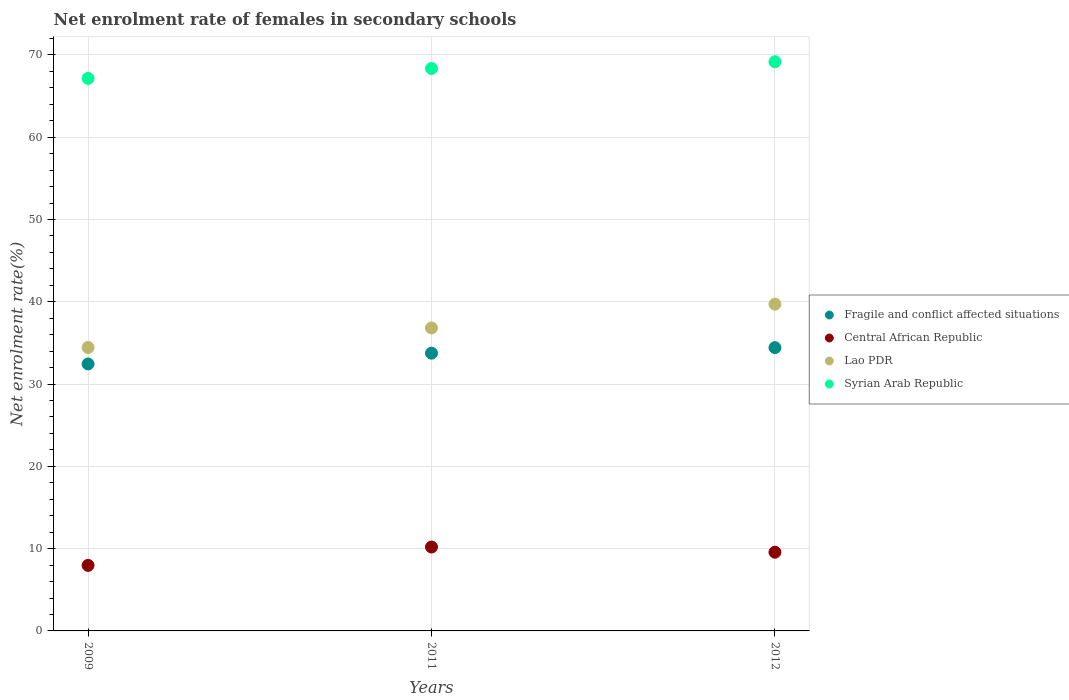How many different coloured dotlines are there?
Provide a succinct answer. 4. What is the net enrolment rate of females in secondary schools in Fragile and conflict affected situations in 2009?
Your response must be concise. 32.44. Across all years, what is the maximum net enrolment rate of females in secondary schools in Central African Republic?
Ensure brevity in your answer.  10.2. Across all years, what is the minimum net enrolment rate of females in secondary schools in Fragile and conflict affected situations?
Ensure brevity in your answer.  32.44. What is the total net enrolment rate of females in secondary schools in Syrian Arab Republic in the graph?
Your response must be concise. 204.66. What is the difference between the net enrolment rate of females in secondary schools in Lao PDR in 2009 and that in 2012?
Ensure brevity in your answer.  -5.27. What is the difference between the net enrolment rate of females in secondary schools in Lao PDR in 2009 and the net enrolment rate of females in secondary schools in Syrian Arab Republic in 2012?
Provide a short and direct response. -34.72. What is the average net enrolment rate of females in secondary schools in Fragile and conflict affected situations per year?
Provide a short and direct response. 33.54. In the year 2012, what is the difference between the net enrolment rate of females in secondary schools in Central African Republic and net enrolment rate of females in secondary schools in Syrian Arab Republic?
Provide a short and direct response. -59.6. What is the ratio of the net enrolment rate of females in secondary schools in Lao PDR in 2011 to that in 2012?
Give a very brief answer. 0.93. Is the net enrolment rate of females in secondary schools in Lao PDR in 2011 less than that in 2012?
Give a very brief answer. Yes. Is the difference between the net enrolment rate of females in secondary schools in Central African Republic in 2009 and 2011 greater than the difference between the net enrolment rate of females in secondary schools in Syrian Arab Republic in 2009 and 2011?
Ensure brevity in your answer.  No. What is the difference between the highest and the second highest net enrolment rate of females in secondary schools in Central African Republic?
Your response must be concise. 0.63. What is the difference between the highest and the lowest net enrolment rate of females in secondary schools in Lao PDR?
Offer a very short reply. 5.27. In how many years, is the net enrolment rate of females in secondary schools in Syrian Arab Republic greater than the average net enrolment rate of females in secondary schools in Syrian Arab Republic taken over all years?
Provide a succinct answer. 2. Is the sum of the net enrolment rate of females in secondary schools in Syrian Arab Republic in 2009 and 2011 greater than the maximum net enrolment rate of females in secondary schools in Lao PDR across all years?
Your answer should be compact. Yes. Is it the case that in every year, the sum of the net enrolment rate of females in secondary schools in Central African Republic and net enrolment rate of females in secondary schools in Fragile and conflict affected situations  is greater than the sum of net enrolment rate of females in secondary schools in Lao PDR and net enrolment rate of females in secondary schools in Syrian Arab Republic?
Offer a terse response. No. Is the net enrolment rate of females in secondary schools in Central African Republic strictly less than the net enrolment rate of females in secondary schools in Syrian Arab Republic over the years?
Your answer should be very brief. Yes. How many years are there in the graph?
Your answer should be compact. 3. What is the difference between two consecutive major ticks on the Y-axis?
Offer a terse response. 10. How many legend labels are there?
Offer a very short reply. 4. How are the legend labels stacked?
Provide a short and direct response. Vertical. What is the title of the graph?
Ensure brevity in your answer.  Net enrolment rate of females in secondary schools. Does "East Asia (developing only)" appear as one of the legend labels in the graph?
Ensure brevity in your answer.  No. What is the label or title of the Y-axis?
Offer a very short reply. Net enrolment rate(%). What is the Net enrolment rate(%) in Fragile and conflict affected situations in 2009?
Make the answer very short. 32.44. What is the Net enrolment rate(%) in Central African Republic in 2009?
Provide a succinct answer. 7.96. What is the Net enrolment rate(%) in Lao PDR in 2009?
Keep it short and to the point. 34.45. What is the Net enrolment rate(%) of Syrian Arab Republic in 2009?
Provide a short and direct response. 67.14. What is the Net enrolment rate(%) of Fragile and conflict affected situations in 2011?
Your answer should be compact. 33.76. What is the Net enrolment rate(%) in Central African Republic in 2011?
Offer a terse response. 10.2. What is the Net enrolment rate(%) in Lao PDR in 2011?
Provide a succinct answer. 36.82. What is the Net enrolment rate(%) of Syrian Arab Republic in 2011?
Make the answer very short. 68.35. What is the Net enrolment rate(%) of Fragile and conflict affected situations in 2012?
Offer a very short reply. 34.43. What is the Net enrolment rate(%) of Central African Republic in 2012?
Keep it short and to the point. 9.57. What is the Net enrolment rate(%) in Lao PDR in 2012?
Provide a succinct answer. 39.71. What is the Net enrolment rate(%) in Syrian Arab Republic in 2012?
Provide a short and direct response. 69.17. Across all years, what is the maximum Net enrolment rate(%) of Fragile and conflict affected situations?
Give a very brief answer. 34.43. Across all years, what is the maximum Net enrolment rate(%) of Central African Republic?
Keep it short and to the point. 10.2. Across all years, what is the maximum Net enrolment rate(%) of Lao PDR?
Offer a terse response. 39.71. Across all years, what is the maximum Net enrolment rate(%) of Syrian Arab Republic?
Make the answer very short. 69.17. Across all years, what is the minimum Net enrolment rate(%) of Fragile and conflict affected situations?
Your answer should be compact. 32.44. Across all years, what is the minimum Net enrolment rate(%) of Central African Republic?
Offer a terse response. 7.96. Across all years, what is the minimum Net enrolment rate(%) in Lao PDR?
Your answer should be compact. 34.45. Across all years, what is the minimum Net enrolment rate(%) of Syrian Arab Republic?
Offer a terse response. 67.14. What is the total Net enrolment rate(%) of Fragile and conflict affected situations in the graph?
Keep it short and to the point. 100.63. What is the total Net enrolment rate(%) of Central African Republic in the graph?
Make the answer very short. 27.73. What is the total Net enrolment rate(%) in Lao PDR in the graph?
Your answer should be very brief. 110.98. What is the total Net enrolment rate(%) of Syrian Arab Republic in the graph?
Give a very brief answer. 204.66. What is the difference between the Net enrolment rate(%) of Fragile and conflict affected situations in 2009 and that in 2011?
Keep it short and to the point. -1.31. What is the difference between the Net enrolment rate(%) of Central African Republic in 2009 and that in 2011?
Make the answer very short. -2.23. What is the difference between the Net enrolment rate(%) of Lao PDR in 2009 and that in 2011?
Your answer should be very brief. -2.37. What is the difference between the Net enrolment rate(%) in Syrian Arab Republic in 2009 and that in 2011?
Provide a succinct answer. -1.21. What is the difference between the Net enrolment rate(%) in Fragile and conflict affected situations in 2009 and that in 2012?
Offer a terse response. -1.98. What is the difference between the Net enrolment rate(%) in Central African Republic in 2009 and that in 2012?
Offer a terse response. -1.6. What is the difference between the Net enrolment rate(%) of Lao PDR in 2009 and that in 2012?
Keep it short and to the point. -5.27. What is the difference between the Net enrolment rate(%) in Syrian Arab Republic in 2009 and that in 2012?
Offer a terse response. -2.02. What is the difference between the Net enrolment rate(%) of Fragile and conflict affected situations in 2011 and that in 2012?
Your answer should be very brief. -0.67. What is the difference between the Net enrolment rate(%) in Central African Republic in 2011 and that in 2012?
Provide a succinct answer. 0.63. What is the difference between the Net enrolment rate(%) of Lao PDR in 2011 and that in 2012?
Make the answer very short. -2.89. What is the difference between the Net enrolment rate(%) of Syrian Arab Republic in 2011 and that in 2012?
Your answer should be very brief. -0.82. What is the difference between the Net enrolment rate(%) of Fragile and conflict affected situations in 2009 and the Net enrolment rate(%) of Central African Republic in 2011?
Provide a succinct answer. 22.25. What is the difference between the Net enrolment rate(%) in Fragile and conflict affected situations in 2009 and the Net enrolment rate(%) in Lao PDR in 2011?
Keep it short and to the point. -4.38. What is the difference between the Net enrolment rate(%) in Fragile and conflict affected situations in 2009 and the Net enrolment rate(%) in Syrian Arab Republic in 2011?
Offer a terse response. -35.91. What is the difference between the Net enrolment rate(%) in Central African Republic in 2009 and the Net enrolment rate(%) in Lao PDR in 2011?
Give a very brief answer. -28.86. What is the difference between the Net enrolment rate(%) of Central African Republic in 2009 and the Net enrolment rate(%) of Syrian Arab Republic in 2011?
Your response must be concise. -60.39. What is the difference between the Net enrolment rate(%) in Lao PDR in 2009 and the Net enrolment rate(%) in Syrian Arab Republic in 2011?
Ensure brevity in your answer.  -33.9. What is the difference between the Net enrolment rate(%) in Fragile and conflict affected situations in 2009 and the Net enrolment rate(%) in Central African Republic in 2012?
Keep it short and to the point. 22.88. What is the difference between the Net enrolment rate(%) of Fragile and conflict affected situations in 2009 and the Net enrolment rate(%) of Lao PDR in 2012?
Give a very brief answer. -7.27. What is the difference between the Net enrolment rate(%) in Fragile and conflict affected situations in 2009 and the Net enrolment rate(%) in Syrian Arab Republic in 2012?
Your answer should be very brief. -36.72. What is the difference between the Net enrolment rate(%) in Central African Republic in 2009 and the Net enrolment rate(%) in Lao PDR in 2012?
Make the answer very short. -31.75. What is the difference between the Net enrolment rate(%) in Central African Republic in 2009 and the Net enrolment rate(%) in Syrian Arab Republic in 2012?
Provide a succinct answer. -61.2. What is the difference between the Net enrolment rate(%) of Lao PDR in 2009 and the Net enrolment rate(%) of Syrian Arab Republic in 2012?
Offer a terse response. -34.72. What is the difference between the Net enrolment rate(%) in Fragile and conflict affected situations in 2011 and the Net enrolment rate(%) in Central African Republic in 2012?
Give a very brief answer. 24.19. What is the difference between the Net enrolment rate(%) of Fragile and conflict affected situations in 2011 and the Net enrolment rate(%) of Lao PDR in 2012?
Offer a terse response. -5.96. What is the difference between the Net enrolment rate(%) in Fragile and conflict affected situations in 2011 and the Net enrolment rate(%) in Syrian Arab Republic in 2012?
Make the answer very short. -35.41. What is the difference between the Net enrolment rate(%) of Central African Republic in 2011 and the Net enrolment rate(%) of Lao PDR in 2012?
Your answer should be very brief. -29.52. What is the difference between the Net enrolment rate(%) of Central African Republic in 2011 and the Net enrolment rate(%) of Syrian Arab Republic in 2012?
Offer a very short reply. -58.97. What is the difference between the Net enrolment rate(%) of Lao PDR in 2011 and the Net enrolment rate(%) of Syrian Arab Republic in 2012?
Give a very brief answer. -32.35. What is the average Net enrolment rate(%) of Fragile and conflict affected situations per year?
Ensure brevity in your answer.  33.54. What is the average Net enrolment rate(%) in Central African Republic per year?
Make the answer very short. 9.24. What is the average Net enrolment rate(%) of Lao PDR per year?
Give a very brief answer. 36.99. What is the average Net enrolment rate(%) of Syrian Arab Republic per year?
Provide a short and direct response. 68.22. In the year 2009, what is the difference between the Net enrolment rate(%) in Fragile and conflict affected situations and Net enrolment rate(%) in Central African Republic?
Your response must be concise. 24.48. In the year 2009, what is the difference between the Net enrolment rate(%) of Fragile and conflict affected situations and Net enrolment rate(%) of Lao PDR?
Offer a terse response. -2. In the year 2009, what is the difference between the Net enrolment rate(%) in Fragile and conflict affected situations and Net enrolment rate(%) in Syrian Arab Republic?
Ensure brevity in your answer.  -34.7. In the year 2009, what is the difference between the Net enrolment rate(%) of Central African Republic and Net enrolment rate(%) of Lao PDR?
Keep it short and to the point. -26.48. In the year 2009, what is the difference between the Net enrolment rate(%) in Central African Republic and Net enrolment rate(%) in Syrian Arab Republic?
Offer a very short reply. -59.18. In the year 2009, what is the difference between the Net enrolment rate(%) in Lao PDR and Net enrolment rate(%) in Syrian Arab Republic?
Your answer should be compact. -32.7. In the year 2011, what is the difference between the Net enrolment rate(%) of Fragile and conflict affected situations and Net enrolment rate(%) of Central African Republic?
Keep it short and to the point. 23.56. In the year 2011, what is the difference between the Net enrolment rate(%) in Fragile and conflict affected situations and Net enrolment rate(%) in Lao PDR?
Offer a terse response. -3.06. In the year 2011, what is the difference between the Net enrolment rate(%) in Fragile and conflict affected situations and Net enrolment rate(%) in Syrian Arab Republic?
Provide a short and direct response. -34.59. In the year 2011, what is the difference between the Net enrolment rate(%) of Central African Republic and Net enrolment rate(%) of Lao PDR?
Give a very brief answer. -26.62. In the year 2011, what is the difference between the Net enrolment rate(%) in Central African Republic and Net enrolment rate(%) in Syrian Arab Republic?
Provide a succinct answer. -58.15. In the year 2011, what is the difference between the Net enrolment rate(%) of Lao PDR and Net enrolment rate(%) of Syrian Arab Republic?
Offer a very short reply. -31.53. In the year 2012, what is the difference between the Net enrolment rate(%) of Fragile and conflict affected situations and Net enrolment rate(%) of Central African Republic?
Your response must be concise. 24.86. In the year 2012, what is the difference between the Net enrolment rate(%) in Fragile and conflict affected situations and Net enrolment rate(%) in Lao PDR?
Your answer should be very brief. -5.28. In the year 2012, what is the difference between the Net enrolment rate(%) in Fragile and conflict affected situations and Net enrolment rate(%) in Syrian Arab Republic?
Make the answer very short. -34.74. In the year 2012, what is the difference between the Net enrolment rate(%) of Central African Republic and Net enrolment rate(%) of Lao PDR?
Keep it short and to the point. -30.15. In the year 2012, what is the difference between the Net enrolment rate(%) of Central African Republic and Net enrolment rate(%) of Syrian Arab Republic?
Your answer should be compact. -59.6. In the year 2012, what is the difference between the Net enrolment rate(%) in Lao PDR and Net enrolment rate(%) in Syrian Arab Republic?
Provide a succinct answer. -29.46. What is the ratio of the Net enrolment rate(%) in Fragile and conflict affected situations in 2009 to that in 2011?
Offer a very short reply. 0.96. What is the ratio of the Net enrolment rate(%) in Central African Republic in 2009 to that in 2011?
Give a very brief answer. 0.78. What is the ratio of the Net enrolment rate(%) in Lao PDR in 2009 to that in 2011?
Ensure brevity in your answer.  0.94. What is the ratio of the Net enrolment rate(%) in Syrian Arab Republic in 2009 to that in 2011?
Your answer should be compact. 0.98. What is the ratio of the Net enrolment rate(%) in Fragile and conflict affected situations in 2009 to that in 2012?
Your response must be concise. 0.94. What is the ratio of the Net enrolment rate(%) in Central African Republic in 2009 to that in 2012?
Your answer should be very brief. 0.83. What is the ratio of the Net enrolment rate(%) in Lao PDR in 2009 to that in 2012?
Provide a succinct answer. 0.87. What is the ratio of the Net enrolment rate(%) of Syrian Arab Republic in 2009 to that in 2012?
Ensure brevity in your answer.  0.97. What is the ratio of the Net enrolment rate(%) of Fragile and conflict affected situations in 2011 to that in 2012?
Offer a very short reply. 0.98. What is the ratio of the Net enrolment rate(%) of Central African Republic in 2011 to that in 2012?
Give a very brief answer. 1.07. What is the ratio of the Net enrolment rate(%) in Lao PDR in 2011 to that in 2012?
Ensure brevity in your answer.  0.93. What is the ratio of the Net enrolment rate(%) in Syrian Arab Republic in 2011 to that in 2012?
Keep it short and to the point. 0.99. What is the difference between the highest and the second highest Net enrolment rate(%) of Fragile and conflict affected situations?
Your response must be concise. 0.67. What is the difference between the highest and the second highest Net enrolment rate(%) of Central African Republic?
Your answer should be very brief. 0.63. What is the difference between the highest and the second highest Net enrolment rate(%) in Lao PDR?
Offer a terse response. 2.89. What is the difference between the highest and the second highest Net enrolment rate(%) in Syrian Arab Republic?
Make the answer very short. 0.82. What is the difference between the highest and the lowest Net enrolment rate(%) of Fragile and conflict affected situations?
Your response must be concise. 1.98. What is the difference between the highest and the lowest Net enrolment rate(%) in Central African Republic?
Your answer should be compact. 2.23. What is the difference between the highest and the lowest Net enrolment rate(%) in Lao PDR?
Provide a short and direct response. 5.27. What is the difference between the highest and the lowest Net enrolment rate(%) of Syrian Arab Republic?
Give a very brief answer. 2.02. 